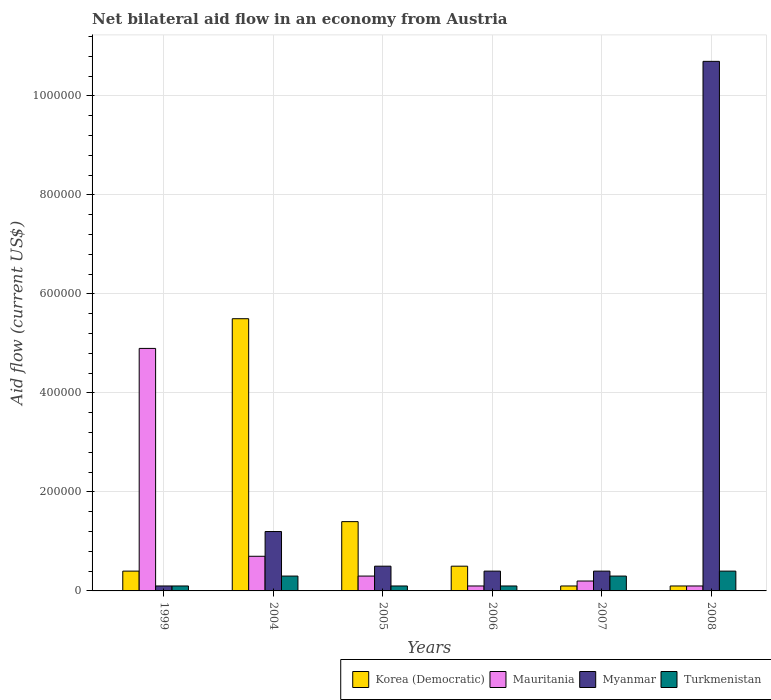How many groups of bars are there?
Make the answer very short. 6. Are the number of bars on each tick of the X-axis equal?
Offer a very short reply. Yes. How many bars are there on the 3rd tick from the left?
Your response must be concise. 4. In how many cases, is the number of bars for a given year not equal to the number of legend labels?
Give a very brief answer. 0. What is the net bilateral aid flow in Turkmenistan in 2005?
Keep it short and to the point. 10000. Across all years, what is the maximum net bilateral aid flow in Myanmar?
Your answer should be compact. 1.07e+06. In which year was the net bilateral aid flow in Myanmar minimum?
Offer a terse response. 1999. What is the total net bilateral aid flow in Myanmar in the graph?
Your answer should be compact. 1.33e+06. What is the average net bilateral aid flow in Korea (Democratic) per year?
Your response must be concise. 1.33e+05. In the year 2008, what is the difference between the net bilateral aid flow in Myanmar and net bilateral aid flow in Turkmenistan?
Your answer should be very brief. 1.03e+06. In how many years, is the net bilateral aid flow in Myanmar greater than 120000 US$?
Ensure brevity in your answer.  1. What is the difference between the highest and the second highest net bilateral aid flow in Korea (Democratic)?
Provide a succinct answer. 4.10e+05. What is the difference between the highest and the lowest net bilateral aid flow in Myanmar?
Your answer should be compact. 1.06e+06. Is the sum of the net bilateral aid flow in Korea (Democratic) in 2006 and 2007 greater than the maximum net bilateral aid flow in Mauritania across all years?
Your answer should be very brief. No. What does the 4th bar from the left in 1999 represents?
Your answer should be compact. Turkmenistan. What does the 4th bar from the right in 2004 represents?
Keep it short and to the point. Korea (Democratic). Is it the case that in every year, the sum of the net bilateral aid flow in Myanmar and net bilateral aid flow in Korea (Democratic) is greater than the net bilateral aid flow in Turkmenistan?
Give a very brief answer. Yes. How many years are there in the graph?
Provide a short and direct response. 6. What is the difference between two consecutive major ticks on the Y-axis?
Your answer should be very brief. 2.00e+05. Does the graph contain any zero values?
Provide a succinct answer. No. Does the graph contain grids?
Your response must be concise. Yes. What is the title of the graph?
Give a very brief answer. Net bilateral aid flow in an economy from Austria. What is the Aid flow (current US$) of Mauritania in 2004?
Give a very brief answer. 7.00e+04. What is the Aid flow (current US$) in Myanmar in 2004?
Offer a terse response. 1.20e+05. What is the Aid flow (current US$) in Turkmenistan in 2004?
Give a very brief answer. 3.00e+04. What is the Aid flow (current US$) of Turkmenistan in 2005?
Your answer should be compact. 10000. What is the Aid flow (current US$) of Korea (Democratic) in 2006?
Provide a succinct answer. 5.00e+04. What is the Aid flow (current US$) of Myanmar in 2006?
Your answer should be very brief. 4.00e+04. What is the Aid flow (current US$) in Turkmenistan in 2006?
Make the answer very short. 10000. What is the Aid flow (current US$) of Korea (Democratic) in 2007?
Your answer should be very brief. 10000. What is the Aid flow (current US$) in Mauritania in 2007?
Provide a short and direct response. 2.00e+04. What is the Aid flow (current US$) of Myanmar in 2007?
Give a very brief answer. 4.00e+04. What is the Aid flow (current US$) in Myanmar in 2008?
Make the answer very short. 1.07e+06. Across all years, what is the maximum Aid flow (current US$) in Korea (Democratic)?
Provide a succinct answer. 5.50e+05. Across all years, what is the maximum Aid flow (current US$) in Mauritania?
Keep it short and to the point. 4.90e+05. Across all years, what is the maximum Aid flow (current US$) of Myanmar?
Ensure brevity in your answer.  1.07e+06. Across all years, what is the minimum Aid flow (current US$) in Mauritania?
Give a very brief answer. 10000. Across all years, what is the minimum Aid flow (current US$) in Myanmar?
Make the answer very short. 10000. What is the total Aid flow (current US$) in Mauritania in the graph?
Keep it short and to the point. 6.30e+05. What is the total Aid flow (current US$) in Myanmar in the graph?
Your answer should be compact. 1.33e+06. What is the difference between the Aid flow (current US$) of Korea (Democratic) in 1999 and that in 2004?
Provide a succinct answer. -5.10e+05. What is the difference between the Aid flow (current US$) of Korea (Democratic) in 1999 and that in 2005?
Keep it short and to the point. -1.00e+05. What is the difference between the Aid flow (current US$) in Mauritania in 1999 and that in 2005?
Give a very brief answer. 4.60e+05. What is the difference between the Aid flow (current US$) of Myanmar in 1999 and that in 2005?
Offer a very short reply. -4.00e+04. What is the difference between the Aid flow (current US$) of Turkmenistan in 1999 and that in 2005?
Your answer should be very brief. 0. What is the difference between the Aid flow (current US$) in Korea (Democratic) in 1999 and that in 2006?
Ensure brevity in your answer.  -10000. What is the difference between the Aid flow (current US$) of Mauritania in 1999 and that in 2006?
Your answer should be very brief. 4.80e+05. What is the difference between the Aid flow (current US$) of Myanmar in 1999 and that in 2006?
Your answer should be very brief. -3.00e+04. What is the difference between the Aid flow (current US$) in Turkmenistan in 1999 and that in 2006?
Give a very brief answer. 0. What is the difference between the Aid flow (current US$) of Korea (Democratic) in 1999 and that in 2007?
Your answer should be very brief. 3.00e+04. What is the difference between the Aid flow (current US$) of Mauritania in 1999 and that in 2007?
Your answer should be very brief. 4.70e+05. What is the difference between the Aid flow (current US$) of Turkmenistan in 1999 and that in 2007?
Ensure brevity in your answer.  -2.00e+04. What is the difference between the Aid flow (current US$) in Korea (Democratic) in 1999 and that in 2008?
Offer a very short reply. 3.00e+04. What is the difference between the Aid flow (current US$) of Mauritania in 1999 and that in 2008?
Your answer should be compact. 4.80e+05. What is the difference between the Aid flow (current US$) of Myanmar in 1999 and that in 2008?
Your answer should be compact. -1.06e+06. What is the difference between the Aid flow (current US$) of Turkmenistan in 1999 and that in 2008?
Give a very brief answer. -3.00e+04. What is the difference between the Aid flow (current US$) of Korea (Democratic) in 2004 and that in 2005?
Provide a succinct answer. 4.10e+05. What is the difference between the Aid flow (current US$) in Mauritania in 2004 and that in 2005?
Your answer should be compact. 4.00e+04. What is the difference between the Aid flow (current US$) of Korea (Democratic) in 2004 and that in 2006?
Your response must be concise. 5.00e+05. What is the difference between the Aid flow (current US$) of Mauritania in 2004 and that in 2006?
Offer a terse response. 6.00e+04. What is the difference between the Aid flow (current US$) of Myanmar in 2004 and that in 2006?
Offer a terse response. 8.00e+04. What is the difference between the Aid flow (current US$) in Korea (Democratic) in 2004 and that in 2007?
Keep it short and to the point. 5.40e+05. What is the difference between the Aid flow (current US$) of Korea (Democratic) in 2004 and that in 2008?
Provide a short and direct response. 5.40e+05. What is the difference between the Aid flow (current US$) of Mauritania in 2004 and that in 2008?
Offer a very short reply. 6.00e+04. What is the difference between the Aid flow (current US$) in Myanmar in 2004 and that in 2008?
Your answer should be very brief. -9.50e+05. What is the difference between the Aid flow (current US$) of Turkmenistan in 2005 and that in 2006?
Provide a succinct answer. 0. What is the difference between the Aid flow (current US$) of Korea (Democratic) in 2005 and that in 2007?
Ensure brevity in your answer.  1.30e+05. What is the difference between the Aid flow (current US$) in Myanmar in 2005 and that in 2007?
Provide a succinct answer. 10000. What is the difference between the Aid flow (current US$) of Korea (Democratic) in 2005 and that in 2008?
Keep it short and to the point. 1.30e+05. What is the difference between the Aid flow (current US$) in Mauritania in 2005 and that in 2008?
Your response must be concise. 2.00e+04. What is the difference between the Aid flow (current US$) of Myanmar in 2005 and that in 2008?
Make the answer very short. -1.02e+06. What is the difference between the Aid flow (current US$) in Turkmenistan in 2005 and that in 2008?
Offer a terse response. -3.00e+04. What is the difference between the Aid flow (current US$) of Korea (Democratic) in 2006 and that in 2008?
Make the answer very short. 4.00e+04. What is the difference between the Aid flow (current US$) of Mauritania in 2006 and that in 2008?
Your answer should be very brief. 0. What is the difference between the Aid flow (current US$) in Myanmar in 2006 and that in 2008?
Your answer should be very brief. -1.03e+06. What is the difference between the Aid flow (current US$) of Turkmenistan in 2006 and that in 2008?
Give a very brief answer. -3.00e+04. What is the difference between the Aid flow (current US$) in Korea (Democratic) in 2007 and that in 2008?
Give a very brief answer. 0. What is the difference between the Aid flow (current US$) in Myanmar in 2007 and that in 2008?
Offer a very short reply. -1.03e+06. What is the difference between the Aid flow (current US$) in Turkmenistan in 2007 and that in 2008?
Offer a very short reply. -10000. What is the difference between the Aid flow (current US$) of Mauritania in 1999 and the Aid flow (current US$) of Myanmar in 2004?
Make the answer very short. 3.70e+05. What is the difference between the Aid flow (current US$) of Mauritania in 1999 and the Aid flow (current US$) of Turkmenistan in 2004?
Offer a terse response. 4.60e+05. What is the difference between the Aid flow (current US$) of Myanmar in 1999 and the Aid flow (current US$) of Turkmenistan in 2004?
Provide a succinct answer. -2.00e+04. What is the difference between the Aid flow (current US$) in Korea (Democratic) in 1999 and the Aid flow (current US$) in Mauritania in 2005?
Your response must be concise. 10000. What is the difference between the Aid flow (current US$) of Korea (Democratic) in 1999 and the Aid flow (current US$) of Myanmar in 2005?
Provide a succinct answer. -10000. What is the difference between the Aid flow (current US$) of Korea (Democratic) in 1999 and the Aid flow (current US$) of Turkmenistan in 2005?
Keep it short and to the point. 3.00e+04. What is the difference between the Aid flow (current US$) of Mauritania in 1999 and the Aid flow (current US$) of Turkmenistan in 2005?
Ensure brevity in your answer.  4.80e+05. What is the difference between the Aid flow (current US$) in Myanmar in 1999 and the Aid flow (current US$) in Turkmenistan in 2005?
Offer a terse response. 0. What is the difference between the Aid flow (current US$) in Mauritania in 1999 and the Aid flow (current US$) in Myanmar in 2006?
Give a very brief answer. 4.50e+05. What is the difference between the Aid flow (current US$) of Mauritania in 1999 and the Aid flow (current US$) of Turkmenistan in 2006?
Offer a very short reply. 4.80e+05. What is the difference between the Aid flow (current US$) in Myanmar in 1999 and the Aid flow (current US$) in Turkmenistan in 2006?
Provide a short and direct response. 0. What is the difference between the Aid flow (current US$) in Korea (Democratic) in 1999 and the Aid flow (current US$) in Mauritania in 2007?
Offer a terse response. 2.00e+04. What is the difference between the Aid flow (current US$) of Korea (Democratic) in 1999 and the Aid flow (current US$) of Myanmar in 2007?
Your answer should be very brief. 0. What is the difference between the Aid flow (current US$) of Mauritania in 1999 and the Aid flow (current US$) of Turkmenistan in 2007?
Your response must be concise. 4.60e+05. What is the difference between the Aid flow (current US$) of Myanmar in 1999 and the Aid flow (current US$) of Turkmenistan in 2007?
Your answer should be very brief. -2.00e+04. What is the difference between the Aid flow (current US$) of Korea (Democratic) in 1999 and the Aid flow (current US$) of Myanmar in 2008?
Offer a terse response. -1.03e+06. What is the difference between the Aid flow (current US$) of Mauritania in 1999 and the Aid flow (current US$) of Myanmar in 2008?
Offer a terse response. -5.80e+05. What is the difference between the Aid flow (current US$) of Mauritania in 1999 and the Aid flow (current US$) of Turkmenistan in 2008?
Provide a succinct answer. 4.50e+05. What is the difference between the Aid flow (current US$) of Myanmar in 1999 and the Aid flow (current US$) of Turkmenistan in 2008?
Your answer should be very brief. -3.00e+04. What is the difference between the Aid flow (current US$) of Korea (Democratic) in 2004 and the Aid flow (current US$) of Mauritania in 2005?
Offer a very short reply. 5.20e+05. What is the difference between the Aid flow (current US$) in Korea (Democratic) in 2004 and the Aid flow (current US$) in Myanmar in 2005?
Offer a terse response. 5.00e+05. What is the difference between the Aid flow (current US$) in Korea (Democratic) in 2004 and the Aid flow (current US$) in Turkmenistan in 2005?
Keep it short and to the point. 5.40e+05. What is the difference between the Aid flow (current US$) in Mauritania in 2004 and the Aid flow (current US$) in Myanmar in 2005?
Your answer should be compact. 2.00e+04. What is the difference between the Aid flow (current US$) of Mauritania in 2004 and the Aid flow (current US$) of Turkmenistan in 2005?
Your response must be concise. 6.00e+04. What is the difference between the Aid flow (current US$) of Korea (Democratic) in 2004 and the Aid flow (current US$) of Mauritania in 2006?
Your answer should be compact. 5.40e+05. What is the difference between the Aid flow (current US$) in Korea (Democratic) in 2004 and the Aid flow (current US$) in Myanmar in 2006?
Your answer should be compact. 5.10e+05. What is the difference between the Aid flow (current US$) of Korea (Democratic) in 2004 and the Aid flow (current US$) of Turkmenistan in 2006?
Your answer should be very brief. 5.40e+05. What is the difference between the Aid flow (current US$) of Mauritania in 2004 and the Aid flow (current US$) of Myanmar in 2006?
Give a very brief answer. 3.00e+04. What is the difference between the Aid flow (current US$) of Korea (Democratic) in 2004 and the Aid flow (current US$) of Mauritania in 2007?
Give a very brief answer. 5.30e+05. What is the difference between the Aid flow (current US$) of Korea (Democratic) in 2004 and the Aid flow (current US$) of Myanmar in 2007?
Provide a short and direct response. 5.10e+05. What is the difference between the Aid flow (current US$) in Korea (Democratic) in 2004 and the Aid flow (current US$) in Turkmenistan in 2007?
Keep it short and to the point. 5.20e+05. What is the difference between the Aid flow (current US$) in Mauritania in 2004 and the Aid flow (current US$) in Myanmar in 2007?
Ensure brevity in your answer.  3.00e+04. What is the difference between the Aid flow (current US$) in Mauritania in 2004 and the Aid flow (current US$) in Turkmenistan in 2007?
Offer a terse response. 4.00e+04. What is the difference between the Aid flow (current US$) in Myanmar in 2004 and the Aid flow (current US$) in Turkmenistan in 2007?
Keep it short and to the point. 9.00e+04. What is the difference between the Aid flow (current US$) in Korea (Democratic) in 2004 and the Aid flow (current US$) in Mauritania in 2008?
Provide a succinct answer. 5.40e+05. What is the difference between the Aid flow (current US$) of Korea (Democratic) in 2004 and the Aid flow (current US$) of Myanmar in 2008?
Your answer should be very brief. -5.20e+05. What is the difference between the Aid flow (current US$) of Korea (Democratic) in 2004 and the Aid flow (current US$) of Turkmenistan in 2008?
Your answer should be very brief. 5.10e+05. What is the difference between the Aid flow (current US$) of Myanmar in 2004 and the Aid flow (current US$) of Turkmenistan in 2008?
Make the answer very short. 8.00e+04. What is the difference between the Aid flow (current US$) in Korea (Democratic) in 2005 and the Aid flow (current US$) in Turkmenistan in 2006?
Offer a terse response. 1.30e+05. What is the difference between the Aid flow (current US$) of Mauritania in 2005 and the Aid flow (current US$) of Myanmar in 2006?
Offer a terse response. -10000. What is the difference between the Aid flow (current US$) of Korea (Democratic) in 2005 and the Aid flow (current US$) of Myanmar in 2007?
Provide a short and direct response. 1.00e+05. What is the difference between the Aid flow (current US$) of Korea (Democratic) in 2005 and the Aid flow (current US$) of Turkmenistan in 2007?
Keep it short and to the point. 1.10e+05. What is the difference between the Aid flow (current US$) of Mauritania in 2005 and the Aid flow (current US$) of Myanmar in 2007?
Provide a short and direct response. -10000. What is the difference between the Aid flow (current US$) of Mauritania in 2005 and the Aid flow (current US$) of Turkmenistan in 2007?
Provide a short and direct response. 0. What is the difference between the Aid flow (current US$) in Korea (Democratic) in 2005 and the Aid flow (current US$) in Myanmar in 2008?
Offer a very short reply. -9.30e+05. What is the difference between the Aid flow (current US$) in Korea (Democratic) in 2005 and the Aid flow (current US$) in Turkmenistan in 2008?
Provide a succinct answer. 1.00e+05. What is the difference between the Aid flow (current US$) in Mauritania in 2005 and the Aid flow (current US$) in Myanmar in 2008?
Offer a very short reply. -1.04e+06. What is the difference between the Aid flow (current US$) in Korea (Democratic) in 2006 and the Aid flow (current US$) in Mauritania in 2007?
Your response must be concise. 3.00e+04. What is the difference between the Aid flow (current US$) of Korea (Democratic) in 2006 and the Aid flow (current US$) of Myanmar in 2008?
Provide a succinct answer. -1.02e+06. What is the difference between the Aid flow (current US$) of Korea (Democratic) in 2006 and the Aid flow (current US$) of Turkmenistan in 2008?
Your answer should be compact. 10000. What is the difference between the Aid flow (current US$) in Mauritania in 2006 and the Aid flow (current US$) in Myanmar in 2008?
Ensure brevity in your answer.  -1.06e+06. What is the difference between the Aid flow (current US$) of Mauritania in 2006 and the Aid flow (current US$) of Turkmenistan in 2008?
Keep it short and to the point. -3.00e+04. What is the difference between the Aid flow (current US$) in Myanmar in 2006 and the Aid flow (current US$) in Turkmenistan in 2008?
Offer a terse response. 0. What is the difference between the Aid flow (current US$) in Korea (Democratic) in 2007 and the Aid flow (current US$) in Myanmar in 2008?
Provide a short and direct response. -1.06e+06. What is the difference between the Aid flow (current US$) in Korea (Democratic) in 2007 and the Aid flow (current US$) in Turkmenistan in 2008?
Ensure brevity in your answer.  -3.00e+04. What is the difference between the Aid flow (current US$) of Mauritania in 2007 and the Aid flow (current US$) of Myanmar in 2008?
Your answer should be compact. -1.05e+06. What is the difference between the Aid flow (current US$) in Myanmar in 2007 and the Aid flow (current US$) in Turkmenistan in 2008?
Provide a succinct answer. 0. What is the average Aid flow (current US$) in Korea (Democratic) per year?
Provide a short and direct response. 1.33e+05. What is the average Aid flow (current US$) of Mauritania per year?
Ensure brevity in your answer.  1.05e+05. What is the average Aid flow (current US$) in Myanmar per year?
Provide a succinct answer. 2.22e+05. What is the average Aid flow (current US$) of Turkmenistan per year?
Your answer should be compact. 2.17e+04. In the year 1999, what is the difference between the Aid flow (current US$) of Korea (Democratic) and Aid flow (current US$) of Mauritania?
Provide a succinct answer. -4.50e+05. In the year 1999, what is the difference between the Aid flow (current US$) of Korea (Democratic) and Aid flow (current US$) of Myanmar?
Keep it short and to the point. 3.00e+04. In the year 1999, what is the difference between the Aid flow (current US$) of Mauritania and Aid flow (current US$) of Myanmar?
Your answer should be very brief. 4.80e+05. In the year 1999, what is the difference between the Aid flow (current US$) of Mauritania and Aid flow (current US$) of Turkmenistan?
Offer a terse response. 4.80e+05. In the year 1999, what is the difference between the Aid flow (current US$) of Myanmar and Aid flow (current US$) of Turkmenistan?
Your answer should be very brief. 0. In the year 2004, what is the difference between the Aid flow (current US$) of Korea (Democratic) and Aid flow (current US$) of Myanmar?
Give a very brief answer. 4.30e+05. In the year 2004, what is the difference between the Aid flow (current US$) of Korea (Democratic) and Aid flow (current US$) of Turkmenistan?
Keep it short and to the point. 5.20e+05. In the year 2004, what is the difference between the Aid flow (current US$) in Mauritania and Aid flow (current US$) in Turkmenistan?
Provide a short and direct response. 4.00e+04. In the year 2005, what is the difference between the Aid flow (current US$) of Korea (Democratic) and Aid flow (current US$) of Turkmenistan?
Offer a very short reply. 1.30e+05. In the year 2005, what is the difference between the Aid flow (current US$) in Mauritania and Aid flow (current US$) in Turkmenistan?
Offer a very short reply. 2.00e+04. In the year 2005, what is the difference between the Aid flow (current US$) in Myanmar and Aid flow (current US$) in Turkmenistan?
Ensure brevity in your answer.  4.00e+04. In the year 2006, what is the difference between the Aid flow (current US$) in Korea (Democratic) and Aid flow (current US$) in Myanmar?
Offer a terse response. 10000. In the year 2006, what is the difference between the Aid flow (current US$) in Korea (Democratic) and Aid flow (current US$) in Turkmenistan?
Provide a short and direct response. 4.00e+04. In the year 2006, what is the difference between the Aid flow (current US$) of Myanmar and Aid flow (current US$) of Turkmenistan?
Give a very brief answer. 3.00e+04. In the year 2007, what is the difference between the Aid flow (current US$) of Korea (Democratic) and Aid flow (current US$) of Myanmar?
Your answer should be very brief. -3.00e+04. In the year 2007, what is the difference between the Aid flow (current US$) of Mauritania and Aid flow (current US$) of Turkmenistan?
Offer a terse response. -10000. In the year 2008, what is the difference between the Aid flow (current US$) in Korea (Democratic) and Aid flow (current US$) in Myanmar?
Keep it short and to the point. -1.06e+06. In the year 2008, what is the difference between the Aid flow (current US$) of Mauritania and Aid flow (current US$) of Myanmar?
Make the answer very short. -1.06e+06. In the year 2008, what is the difference between the Aid flow (current US$) in Mauritania and Aid flow (current US$) in Turkmenistan?
Offer a terse response. -3.00e+04. In the year 2008, what is the difference between the Aid flow (current US$) of Myanmar and Aid flow (current US$) of Turkmenistan?
Make the answer very short. 1.03e+06. What is the ratio of the Aid flow (current US$) of Korea (Democratic) in 1999 to that in 2004?
Your response must be concise. 0.07. What is the ratio of the Aid flow (current US$) in Myanmar in 1999 to that in 2004?
Keep it short and to the point. 0.08. What is the ratio of the Aid flow (current US$) in Turkmenistan in 1999 to that in 2004?
Offer a very short reply. 0.33. What is the ratio of the Aid flow (current US$) in Korea (Democratic) in 1999 to that in 2005?
Make the answer very short. 0.29. What is the ratio of the Aid flow (current US$) in Mauritania in 1999 to that in 2005?
Your response must be concise. 16.33. What is the ratio of the Aid flow (current US$) in Myanmar in 1999 to that in 2005?
Give a very brief answer. 0.2. What is the ratio of the Aid flow (current US$) in Turkmenistan in 1999 to that in 2005?
Your answer should be compact. 1. What is the ratio of the Aid flow (current US$) of Mauritania in 1999 to that in 2006?
Ensure brevity in your answer.  49. What is the ratio of the Aid flow (current US$) in Mauritania in 1999 to that in 2007?
Your response must be concise. 24.5. What is the ratio of the Aid flow (current US$) of Myanmar in 1999 to that in 2007?
Your answer should be very brief. 0.25. What is the ratio of the Aid flow (current US$) of Turkmenistan in 1999 to that in 2007?
Your answer should be very brief. 0.33. What is the ratio of the Aid flow (current US$) of Mauritania in 1999 to that in 2008?
Ensure brevity in your answer.  49. What is the ratio of the Aid flow (current US$) of Myanmar in 1999 to that in 2008?
Give a very brief answer. 0.01. What is the ratio of the Aid flow (current US$) of Korea (Democratic) in 2004 to that in 2005?
Make the answer very short. 3.93. What is the ratio of the Aid flow (current US$) in Mauritania in 2004 to that in 2005?
Keep it short and to the point. 2.33. What is the ratio of the Aid flow (current US$) in Turkmenistan in 2004 to that in 2005?
Your answer should be very brief. 3. What is the ratio of the Aid flow (current US$) of Korea (Democratic) in 2004 to that in 2006?
Keep it short and to the point. 11. What is the ratio of the Aid flow (current US$) in Mauritania in 2004 to that in 2006?
Your response must be concise. 7. What is the ratio of the Aid flow (current US$) in Myanmar in 2004 to that in 2006?
Give a very brief answer. 3. What is the ratio of the Aid flow (current US$) in Mauritania in 2004 to that in 2008?
Give a very brief answer. 7. What is the ratio of the Aid flow (current US$) in Myanmar in 2004 to that in 2008?
Offer a very short reply. 0.11. What is the ratio of the Aid flow (current US$) of Myanmar in 2005 to that in 2006?
Provide a succinct answer. 1.25. What is the ratio of the Aid flow (current US$) of Korea (Democratic) in 2005 to that in 2007?
Keep it short and to the point. 14. What is the ratio of the Aid flow (current US$) of Myanmar in 2005 to that in 2007?
Your response must be concise. 1.25. What is the ratio of the Aid flow (current US$) in Korea (Democratic) in 2005 to that in 2008?
Offer a very short reply. 14. What is the ratio of the Aid flow (current US$) in Myanmar in 2005 to that in 2008?
Give a very brief answer. 0.05. What is the ratio of the Aid flow (current US$) in Turkmenistan in 2005 to that in 2008?
Offer a terse response. 0.25. What is the ratio of the Aid flow (current US$) in Mauritania in 2006 to that in 2007?
Provide a short and direct response. 0.5. What is the ratio of the Aid flow (current US$) in Turkmenistan in 2006 to that in 2007?
Your answer should be very brief. 0.33. What is the ratio of the Aid flow (current US$) in Myanmar in 2006 to that in 2008?
Provide a succinct answer. 0.04. What is the ratio of the Aid flow (current US$) in Turkmenistan in 2006 to that in 2008?
Your answer should be compact. 0.25. What is the ratio of the Aid flow (current US$) in Mauritania in 2007 to that in 2008?
Give a very brief answer. 2. What is the ratio of the Aid flow (current US$) of Myanmar in 2007 to that in 2008?
Keep it short and to the point. 0.04. What is the ratio of the Aid flow (current US$) in Turkmenistan in 2007 to that in 2008?
Make the answer very short. 0.75. What is the difference between the highest and the second highest Aid flow (current US$) of Korea (Democratic)?
Provide a short and direct response. 4.10e+05. What is the difference between the highest and the second highest Aid flow (current US$) of Mauritania?
Offer a terse response. 4.20e+05. What is the difference between the highest and the second highest Aid flow (current US$) of Myanmar?
Give a very brief answer. 9.50e+05. What is the difference between the highest and the second highest Aid flow (current US$) of Turkmenistan?
Provide a succinct answer. 10000. What is the difference between the highest and the lowest Aid flow (current US$) of Korea (Democratic)?
Provide a short and direct response. 5.40e+05. What is the difference between the highest and the lowest Aid flow (current US$) of Myanmar?
Your response must be concise. 1.06e+06. What is the difference between the highest and the lowest Aid flow (current US$) in Turkmenistan?
Offer a terse response. 3.00e+04. 